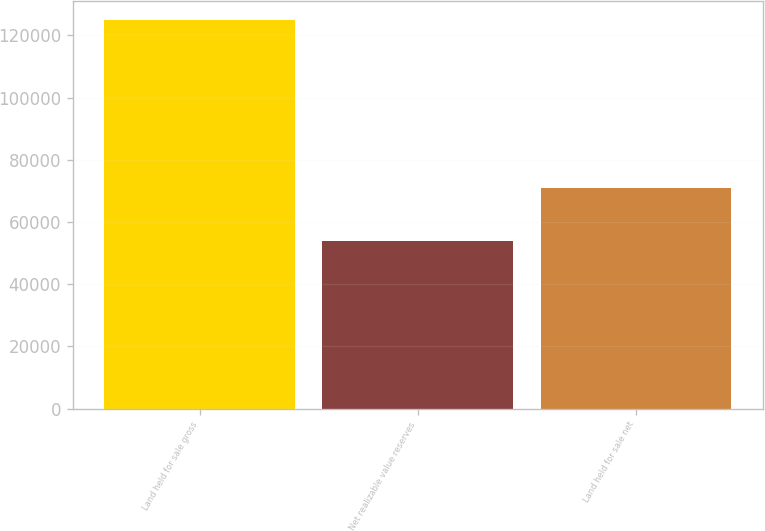Convert chart to OTSL. <chart><loc_0><loc_0><loc_500><loc_500><bar_chart><fcel>Land held for sale gross<fcel>Net realizable value reserves<fcel>Land held for sale net<nl><fcel>124919<fcel>53864<fcel>71055<nl></chart> 